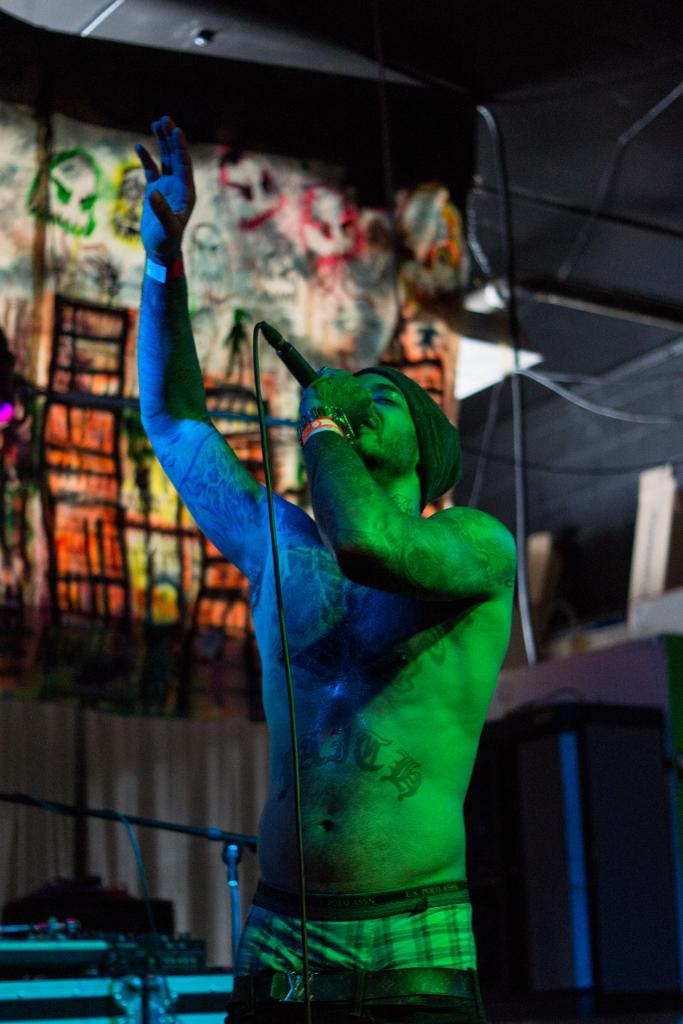Who is present in the image? There is a man in the image. What is the man wearing on his head? The man is wearing a cap. What is the man holding in his hand? The man is holding a mic. What can be seen in the background of the image? There is a mic stand, a light, and other objects in the background of the image. What type of coat is the man wearing in the image? The man is not wearing a coat in the image; he is wearing a cap. How does the man wave to the audience in the image? The man is not waving to the audience in the image; he is holding a mic. 